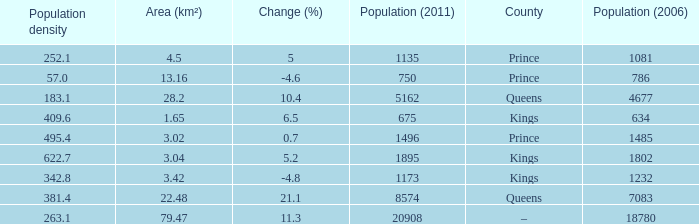What was the Area (km²) when the Population (2011) was 8574, and the Population density was larger than 381.4? None. 